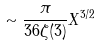<formula> <loc_0><loc_0><loc_500><loc_500>\sim \frac { \pi } { 3 6 \zeta ( 3 ) } X ^ { 3 / 2 }</formula> 